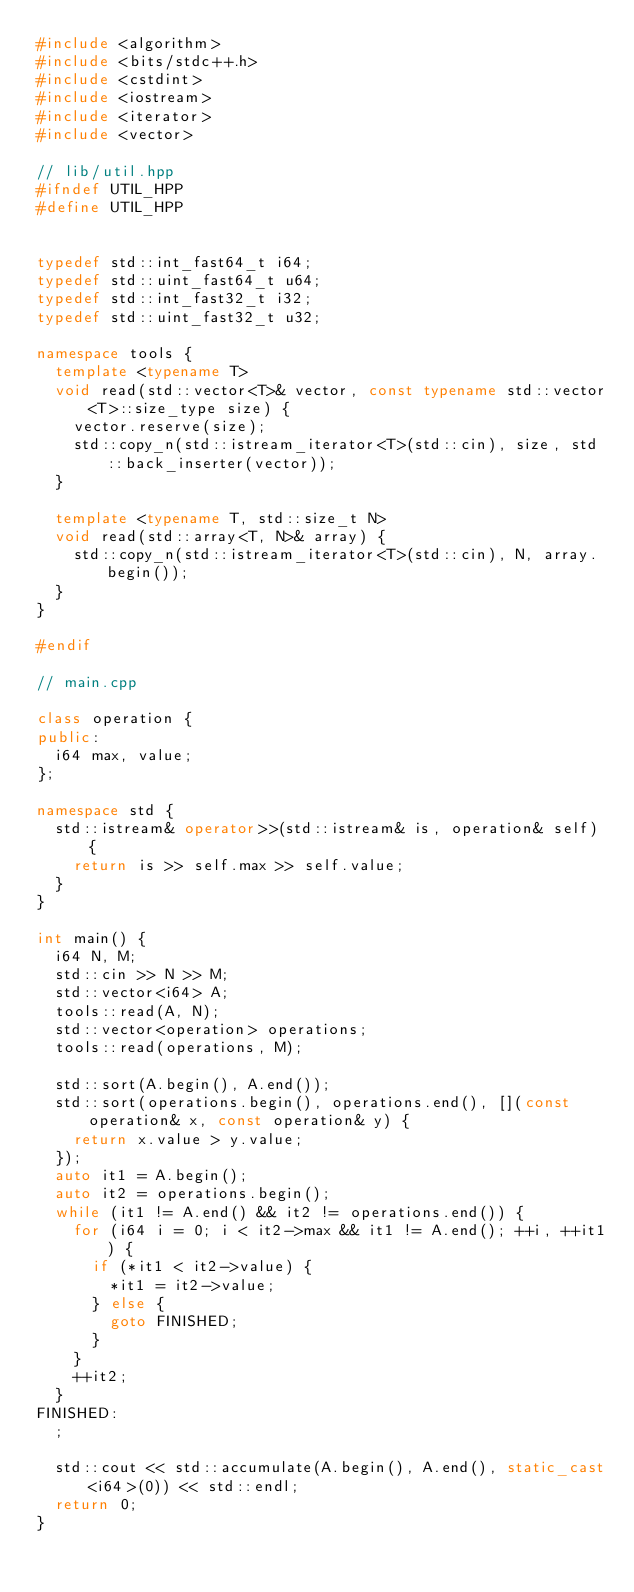<code> <loc_0><loc_0><loc_500><loc_500><_C++_>#include <algorithm>
#include <bits/stdc++.h>
#include <cstdint>
#include <iostream>
#include <iterator>
#include <vector>

// lib/util.hpp
#ifndef UTIL_HPP
#define UTIL_HPP


typedef std::int_fast64_t i64;
typedef std::uint_fast64_t u64;
typedef std::int_fast32_t i32;
typedef std::uint_fast32_t u32;

namespace tools {
  template <typename T>
  void read(std::vector<T>& vector, const typename std::vector<T>::size_type size) {
    vector.reserve(size);
    std::copy_n(std::istream_iterator<T>(std::cin), size, std::back_inserter(vector));
  }

  template <typename T, std::size_t N>
  void read(std::array<T, N>& array) {
    std::copy_n(std::istream_iterator<T>(std::cin), N, array.begin());
  }
}

#endif

// main.cpp

class operation {
public:
  i64 max, value;
};

namespace std {
  std::istream& operator>>(std::istream& is, operation& self) {
    return is >> self.max >> self.value;
  }
}

int main() {
  i64 N, M;
  std::cin >> N >> M;
  std::vector<i64> A;
  tools::read(A, N);
  std::vector<operation> operations;
  tools::read(operations, M);

  std::sort(A.begin(), A.end());
  std::sort(operations.begin(), operations.end(), [](const operation& x, const operation& y) {
    return x.value > y.value;
  });
  auto it1 = A.begin();
  auto it2 = operations.begin();
  while (it1 != A.end() && it2 != operations.end()) {
    for (i64 i = 0; i < it2->max && it1 != A.end(); ++i, ++it1) {
      if (*it1 < it2->value) {
        *it1 = it2->value;
      } else {
        goto FINISHED;
      }
    }
    ++it2;
  }
FINISHED:
  ;

  std::cout << std::accumulate(A.begin(), A.end(), static_cast<i64>(0)) << std::endl;
  return 0;
}</code> 